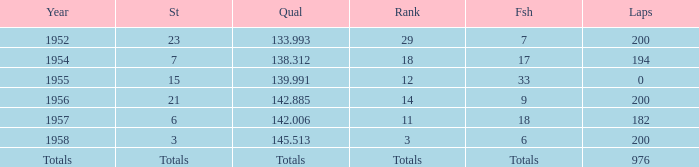What place did Jimmy Reece finish in 1957? 18.0. 